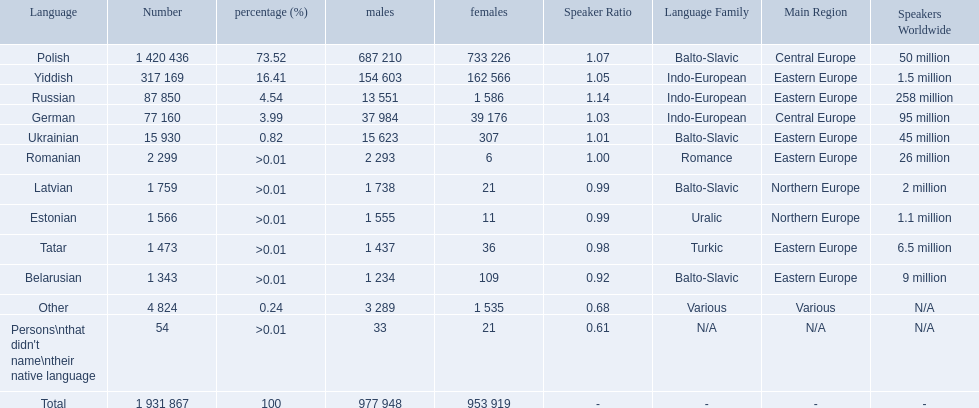What languages are spoken in the warsaw governorate? Polish, Yiddish, Russian, German, Ukrainian, Romanian, Latvian, Estonian, Tatar, Belarusian. Which are the top five languages? Polish, Yiddish, Russian, German, Ukrainian. Of those which is the 2nd most frequently spoken? Yiddish. What are all of the languages Polish, Yiddish, Russian, German, Ukrainian, Romanian, Latvian, Estonian, Tatar, Belarusian, Other, Persons\nthat didn't name\ntheir native language. What was the percentage of each? 73.52, 16.41, 4.54, 3.99, 0.82, >0.01, >0.01, >0.01, >0.01, >0.01, 0.24, >0.01. Which languages had a >0.01	 percentage? Romanian, Latvian, Estonian, Tatar, Belarusian. And of those, which is listed first? Romanian. 